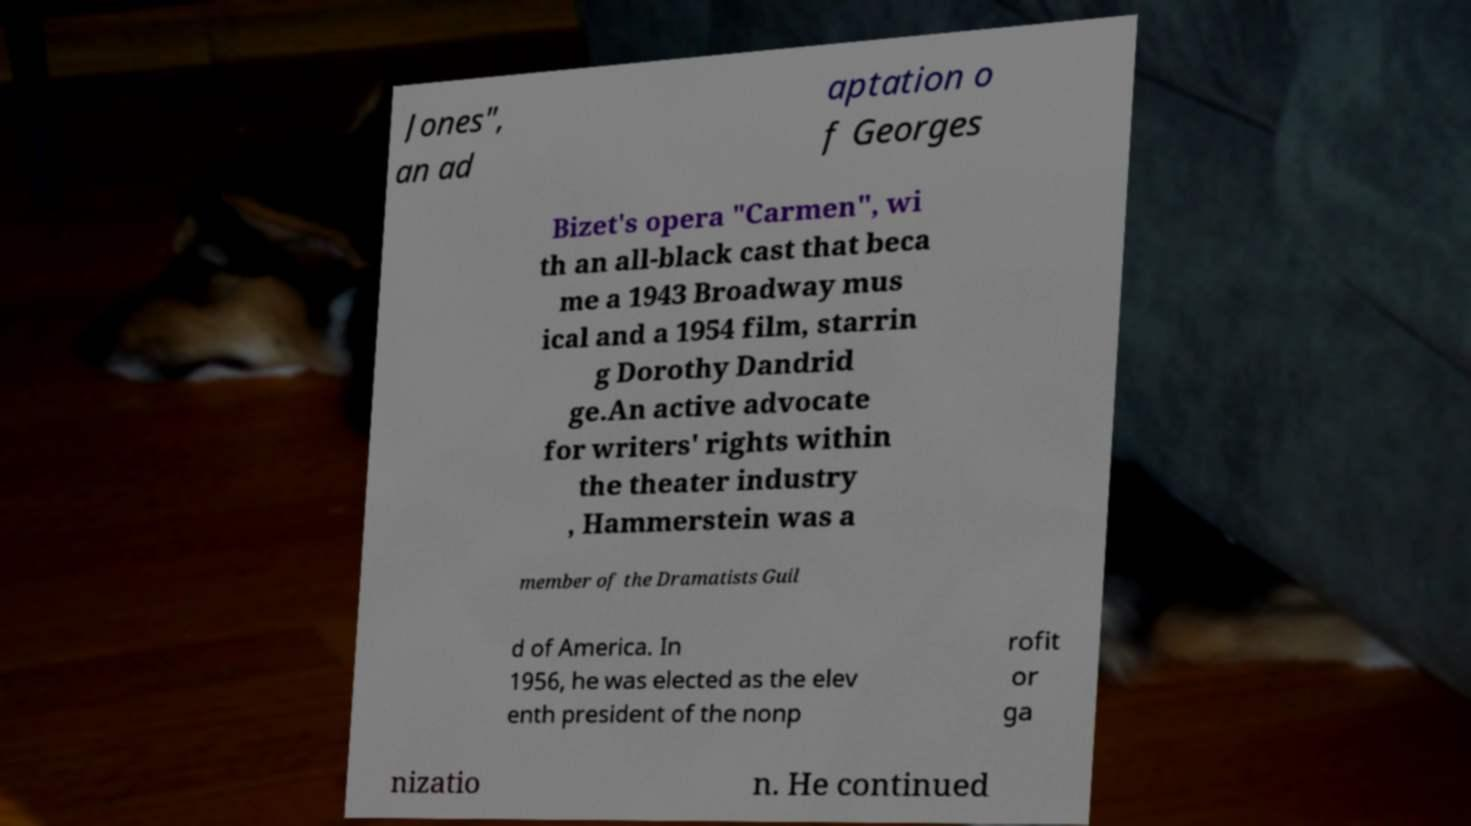There's text embedded in this image that I need extracted. Can you transcribe it verbatim? Jones", an ad aptation o f Georges Bizet's opera "Carmen", wi th an all-black cast that beca me a 1943 Broadway mus ical and a 1954 film, starrin g Dorothy Dandrid ge.An active advocate for writers' rights within the theater industry , Hammerstein was a member of the Dramatists Guil d of America. In 1956, he was elected as the elev enth president of the nonp rofit or ga nizatio n. He continued 